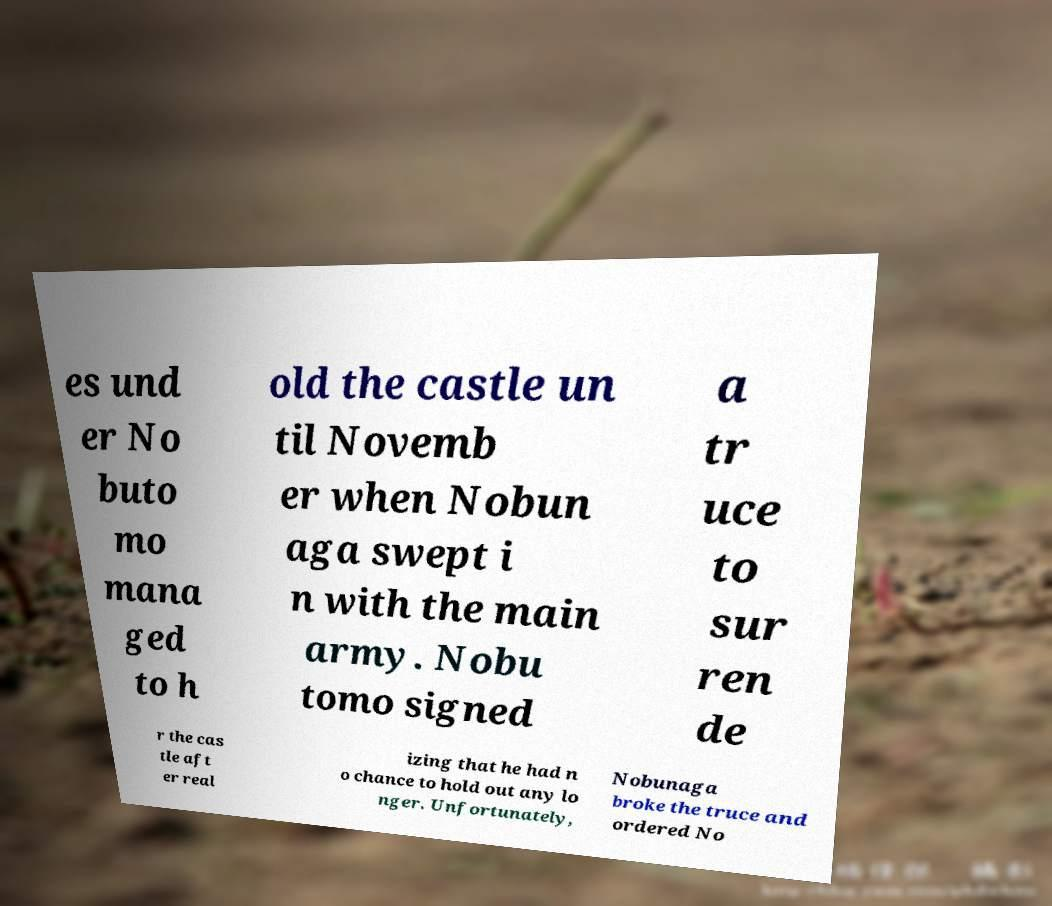Could you extract and type out the text from this image? es und er No buto mo mana ged to h old the castle un til Novemb er when Nobun aga swept i n with the main army. Nobu tomo signed a tr uce to sur ren de r the cas tle aft er real izing that he had n o chance to hold out any lo nger. Unfortunately, Nobunaga broke the truce and ordered No 